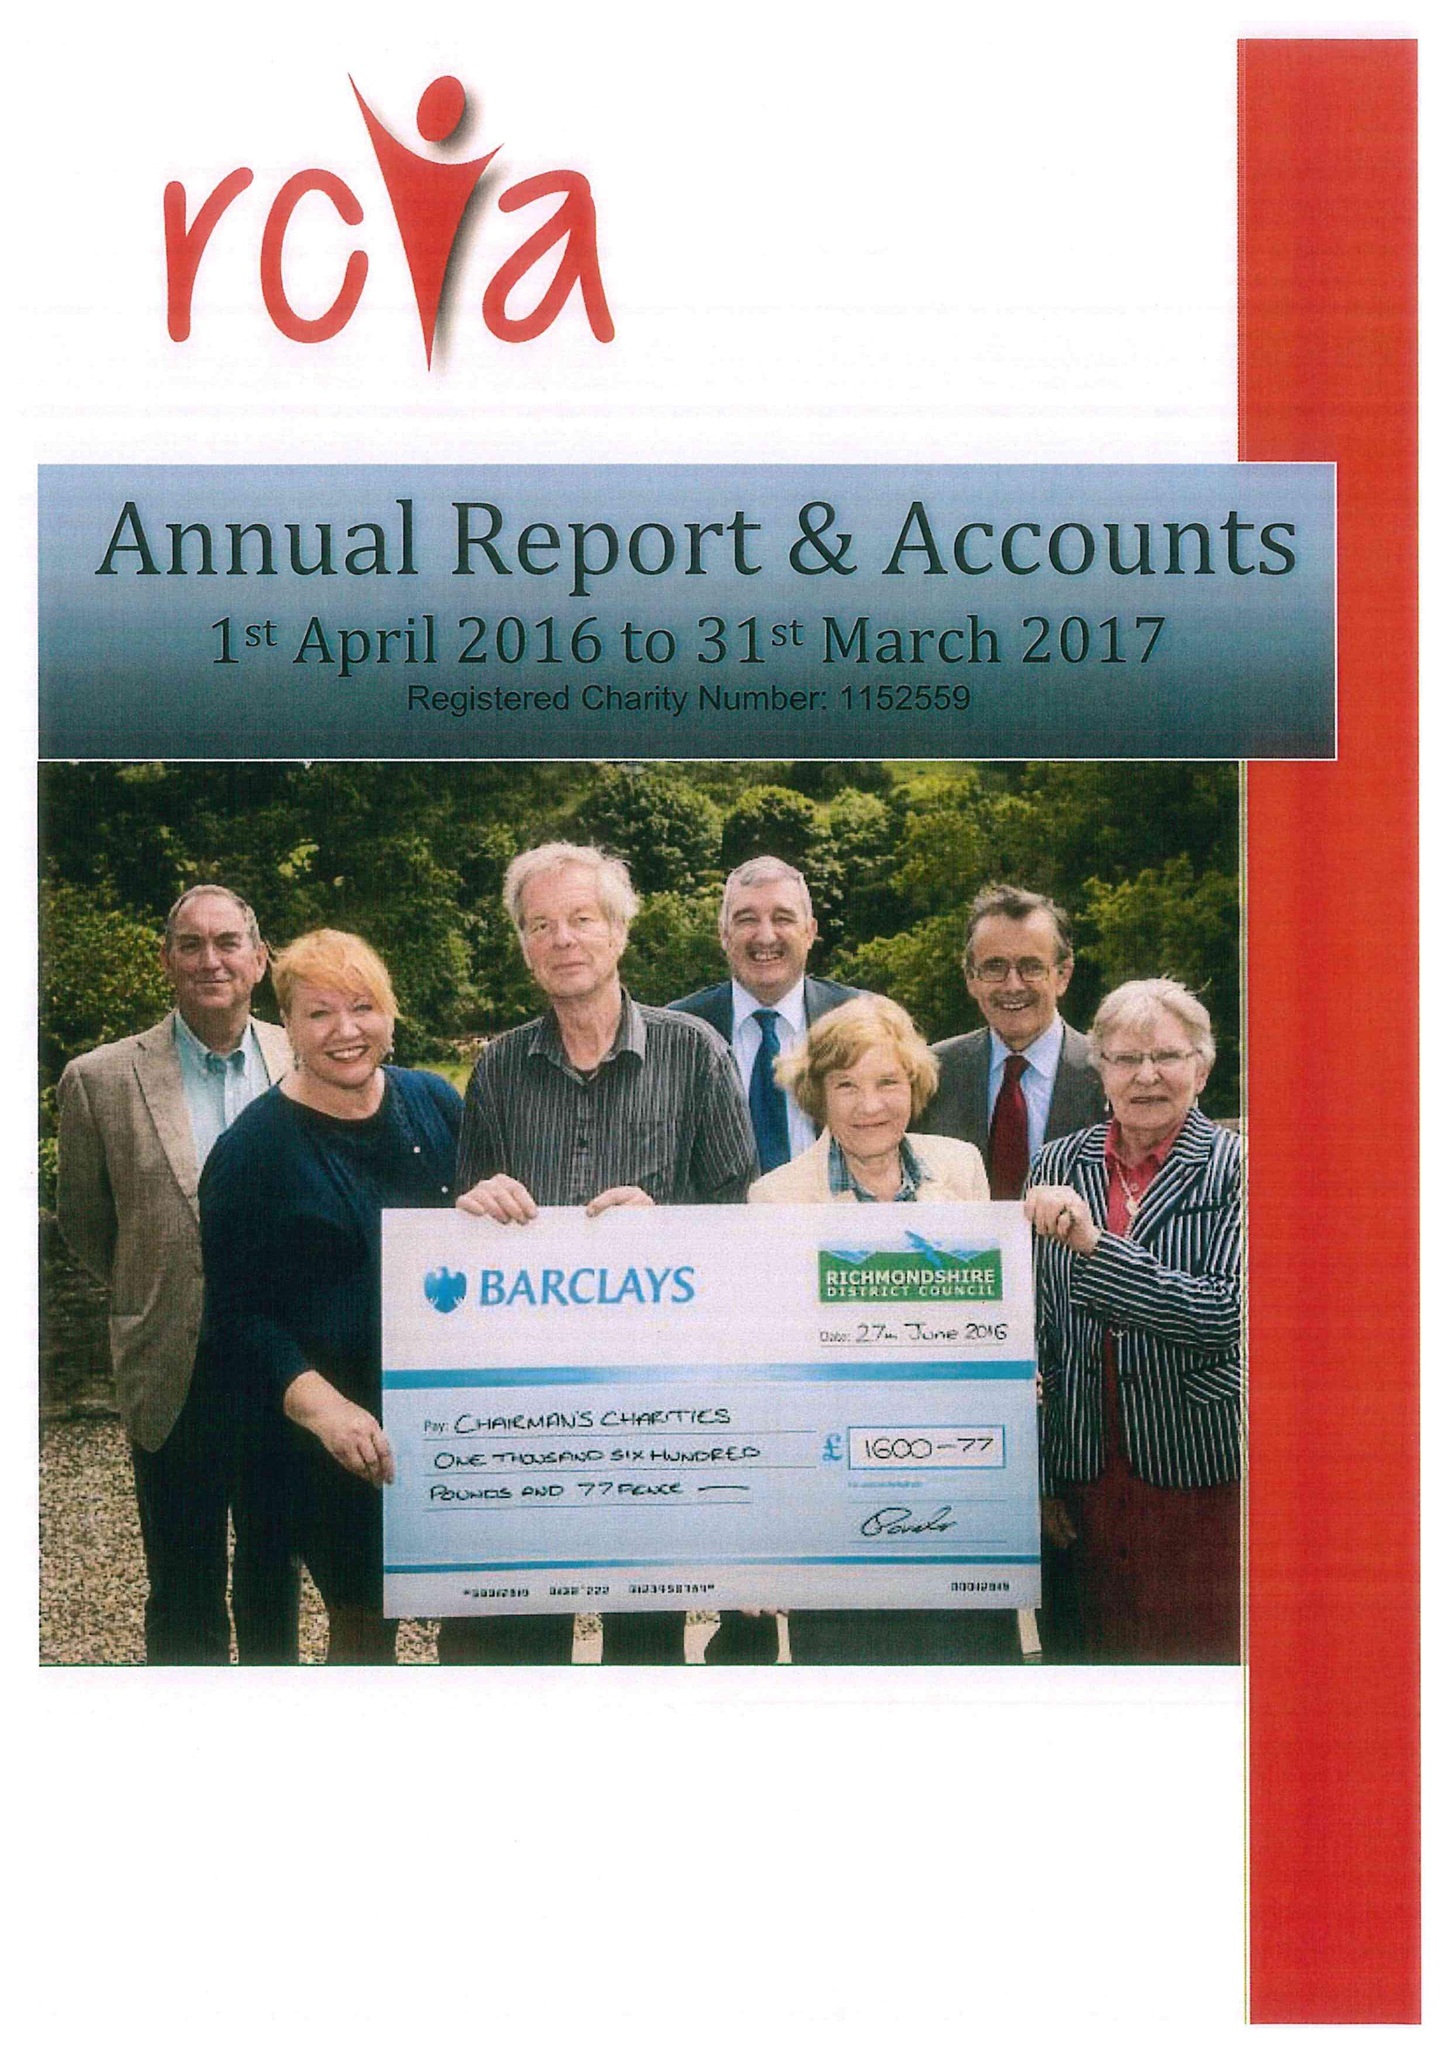What is the value for the charity_name?
Answer the question using a single word or phrase. Richmondshire Community and Voluntary Action 